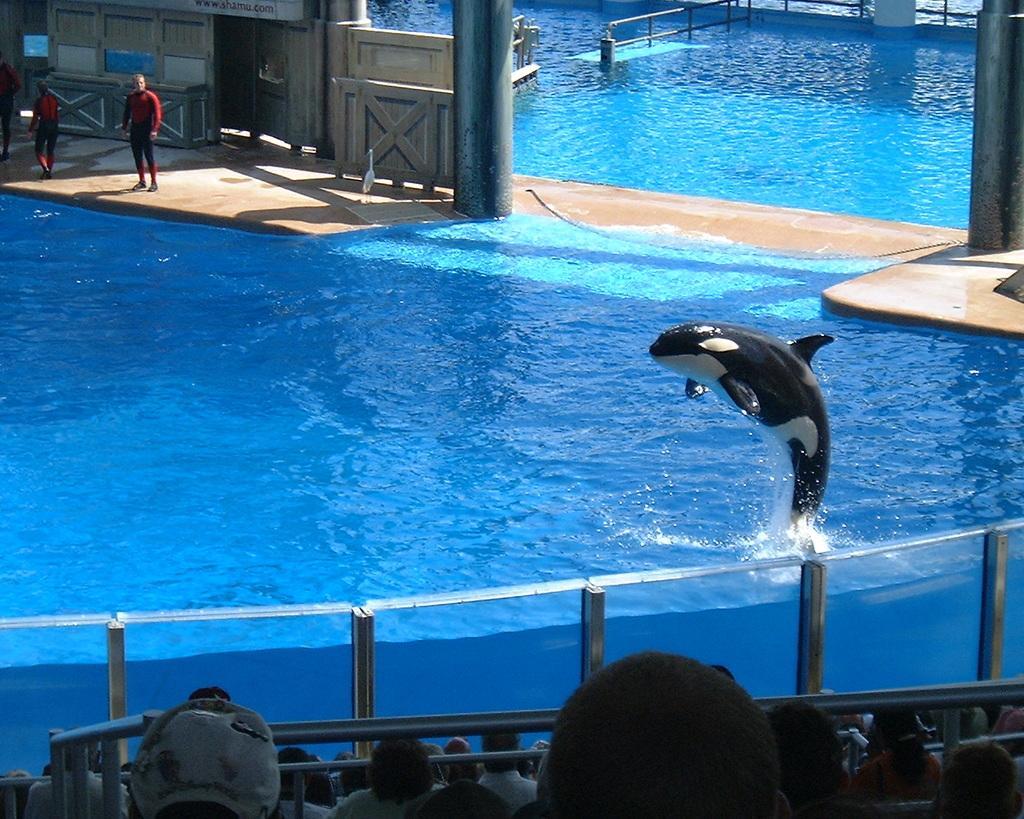Please provide a concise description of this image. In this image on the left side I can see a dolphin jumping out of the water and on the left side there are some people standing. 